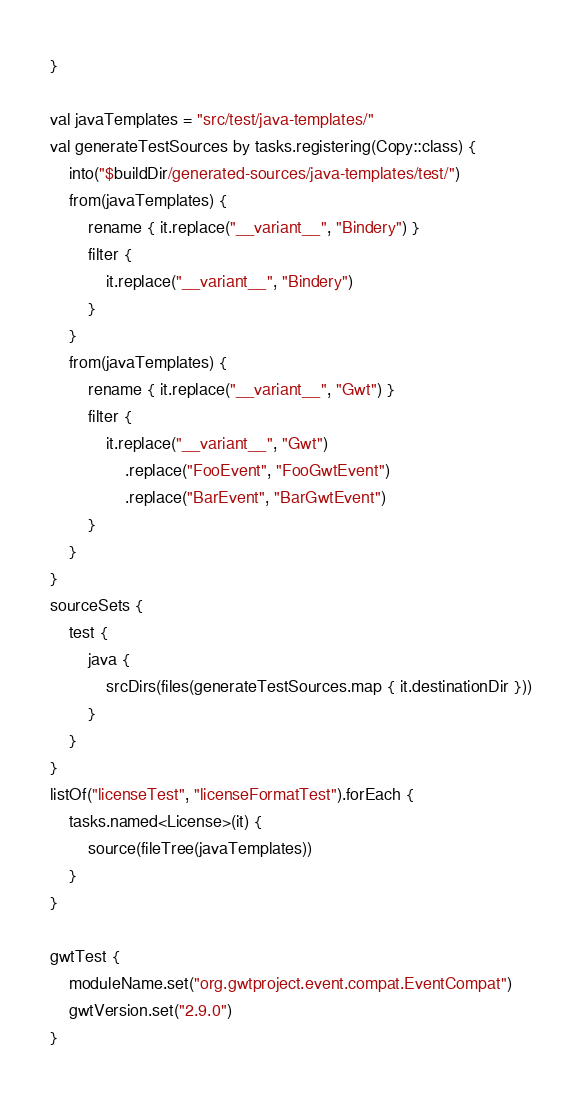Convert code to text. <code><loc_0><loc_0><loc_500><loc_500><_Kotlin_>}

val javaTemplates = "src/test/java-templates/"
val generateTestSources by tasks.registering(Copy::class) {
    into("$buildDir/generated-sources/java-templates/test/")
    from(javaTemplates) {
        rename { it.replace("__variant__", "Bindery") }
        filter {
            it.replace("__variant__", "Bindery")
        }
    }
    from(javaTemplates) {
        rename { it.replace("__variant__", "Gwt") }
        filter {
            it.replace("__variant__", "Gwt")
                .replace("FooEvent", "FooGwtEvent")
                .replace("BarEvent", "BarGwtEvent")
        }
    }
}
sourceSets {
    test {
        java {
            srcDirs(files(generateTestSources.map { it.destinationDir }))
        }
    }
}
listOf("licenseTest", "licenseFormatTest").forEach {
    tasks.named<License>(it) {
        source(fileTree(javaTemplates))
    }
}

gwtTest {
    moduleName.set("org.gwtproject.event.compat.EventCompat")
    gwtVersion.set("2.9.0")
}
</code> 